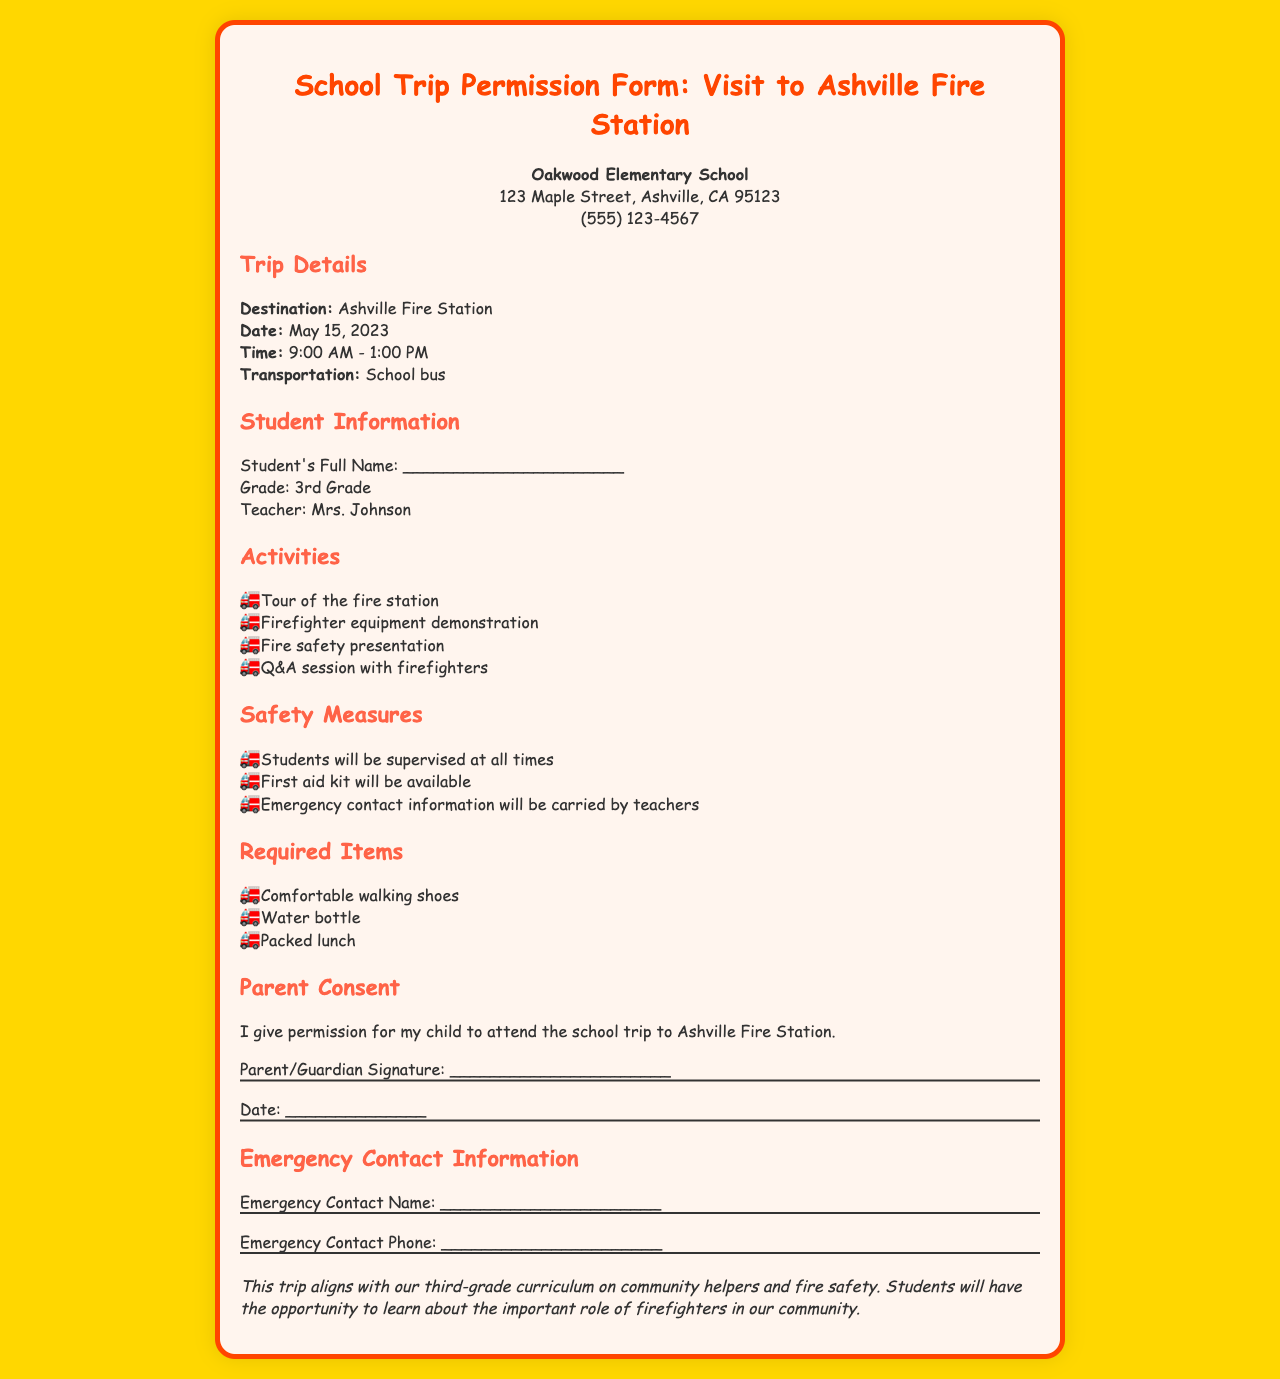What is the destination of the trip? The destination of the trip is mentioned in the Trip Details section.
Answer: Ashville Fire Station What is the date of the trip? The date of the trip is specified in the Trip Details section.
Answer: May 15, 2023 What time will the trip take place? The time is listed in the Trip Details section of the document.
Answer: 9:00 AM - 1:00 PM Who is the teacher for the third grade? The teacher's name can be found in the Student Information section.
Answer: Mrs. Johnson What activities will students participate in? The activities are detailed in the Activities section.
Answer: Tour of the fire station What is one required item for the trip? The required items are listed in the Required Items section.
Answer: Comfortable walking shoes What safety measure is mentioned for the trip? The safety measures are outlined in the Safety Measures section of the document.
Answer: Students will be supervised at all times What is the purpose of the trip mentioned in the additional info? The purpose is stated in the Additional Information section.
Answer: Community helpers and fire safety What must a parent or guardian do for consent? The requirement for consent is mentioned in the Parent Consent section.
Answer: Give permission What transportation will be used for the trip? The mode of transportation is listed in the Trip Details section.
Answer: School bus 